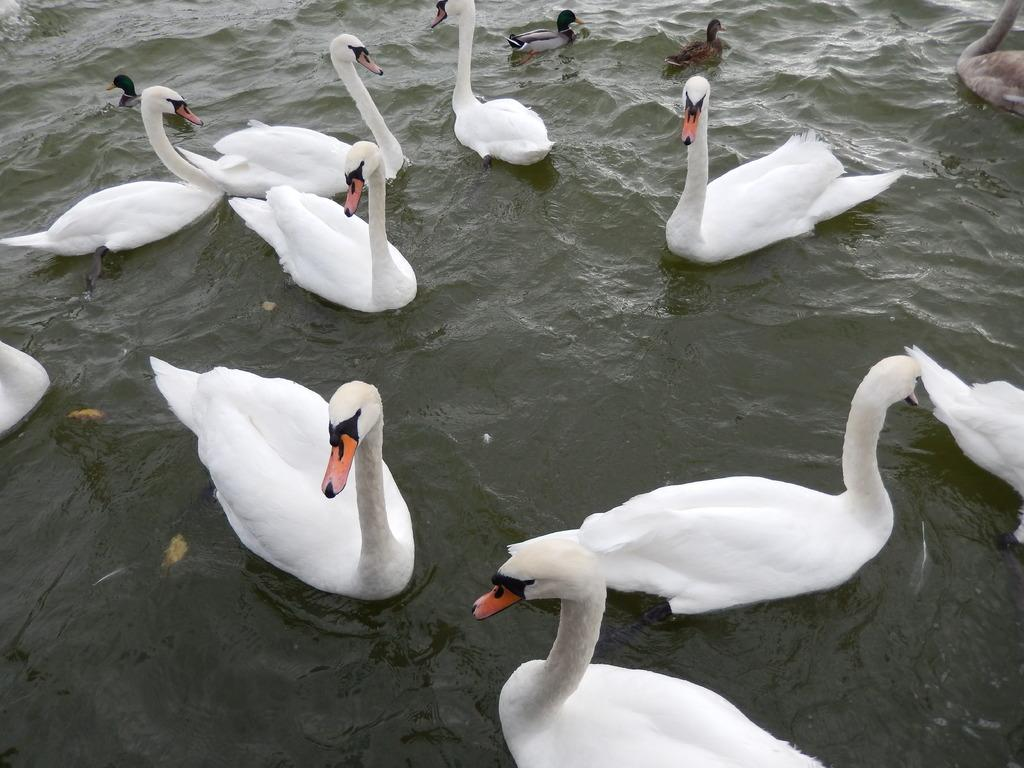What type of animals can be seen in the image? Birds can be seen in the image. What is the primary element in which the birds are situated? The birds are situated in water. How many brothers are present in the image? There are no brothers present in the image; it features birds in the water. Can you spot a ladybug on any of the birds in the image? There is no ladybug visible on any of the birds in the image. 